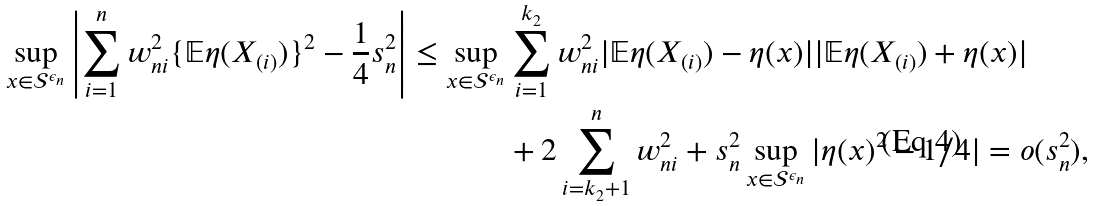Convert formula to latex. <formula><loc_0><loc_0><loc_500><loc_500>\sup _ { x \in \mathcal { S } ^ { \epsilon _ { n } } } \left | \sum _ { i = 1 } ^ { n } w _ { n i } ^ { 2 } \{ \mathbb { E } \eta ( X _ { ( i ) } ) \} ^ { 2 } - \frac { 1 } { 4 } s _ { n } ^ { 2 } \right | \leq \sup _ { x \in \mathcal { S } ^ { \epsilon _ { n } } } & \sum _ { i = 1 } ^ { k _ { 2 } } w _ { n i } ^ { 2 } | \mathbb { E } \eta ( X _ { ( i ) } ) - \eta ( x ) | | \mathbb { E } \eta ( X _ { ( i ) } ) + \eta ( x ) | \\ & + 2 \sum _ { i = k _ { 2 } + 1 } ^ { n } w _ { n i } ^ { 2 } + s _ { n } ^ { 2 } \sup _ { x \in \mathcal { S } ^ { \epsilon _ { n } } } | \eta ( x ) ^ { 2 } - 1 / 4 | = o ( s _ { n } ^ { 2 } ) ,</formula> 